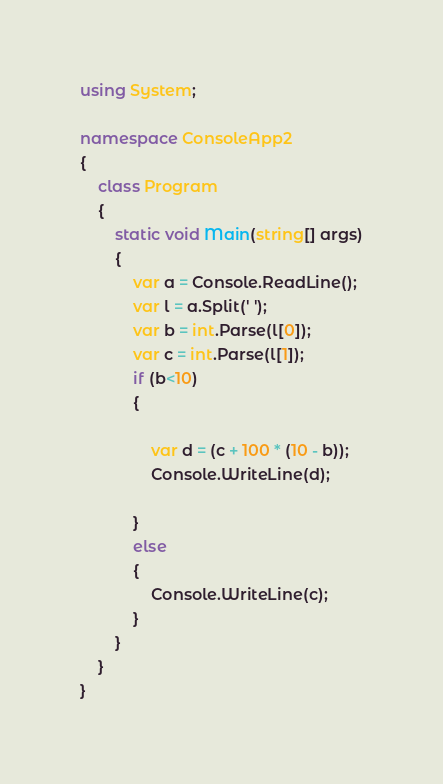<code> <loc_0><loc_0><loc_500><loc_500><_C#_>using System;

namespace ConsoleApp2
{
    class Program
    {
        static void Main(string[] args)
        {
            var a = Console.ReadLine();
            var l = a.Split(' ');
            var b = int.Parse(l[0]);
            var c = int.Parse(l[1]);
            if (b<10)
            {

                var d = (c + 100 * (10 - b));
                Console.WriteLine(d);
                
            }
            else
            {
                Console.WriteLine(c);
            }
        }
    }
}
</code> 